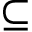<formula> <loc_0><loc_0><loc_500><loc_500>\subseteq</formula> 